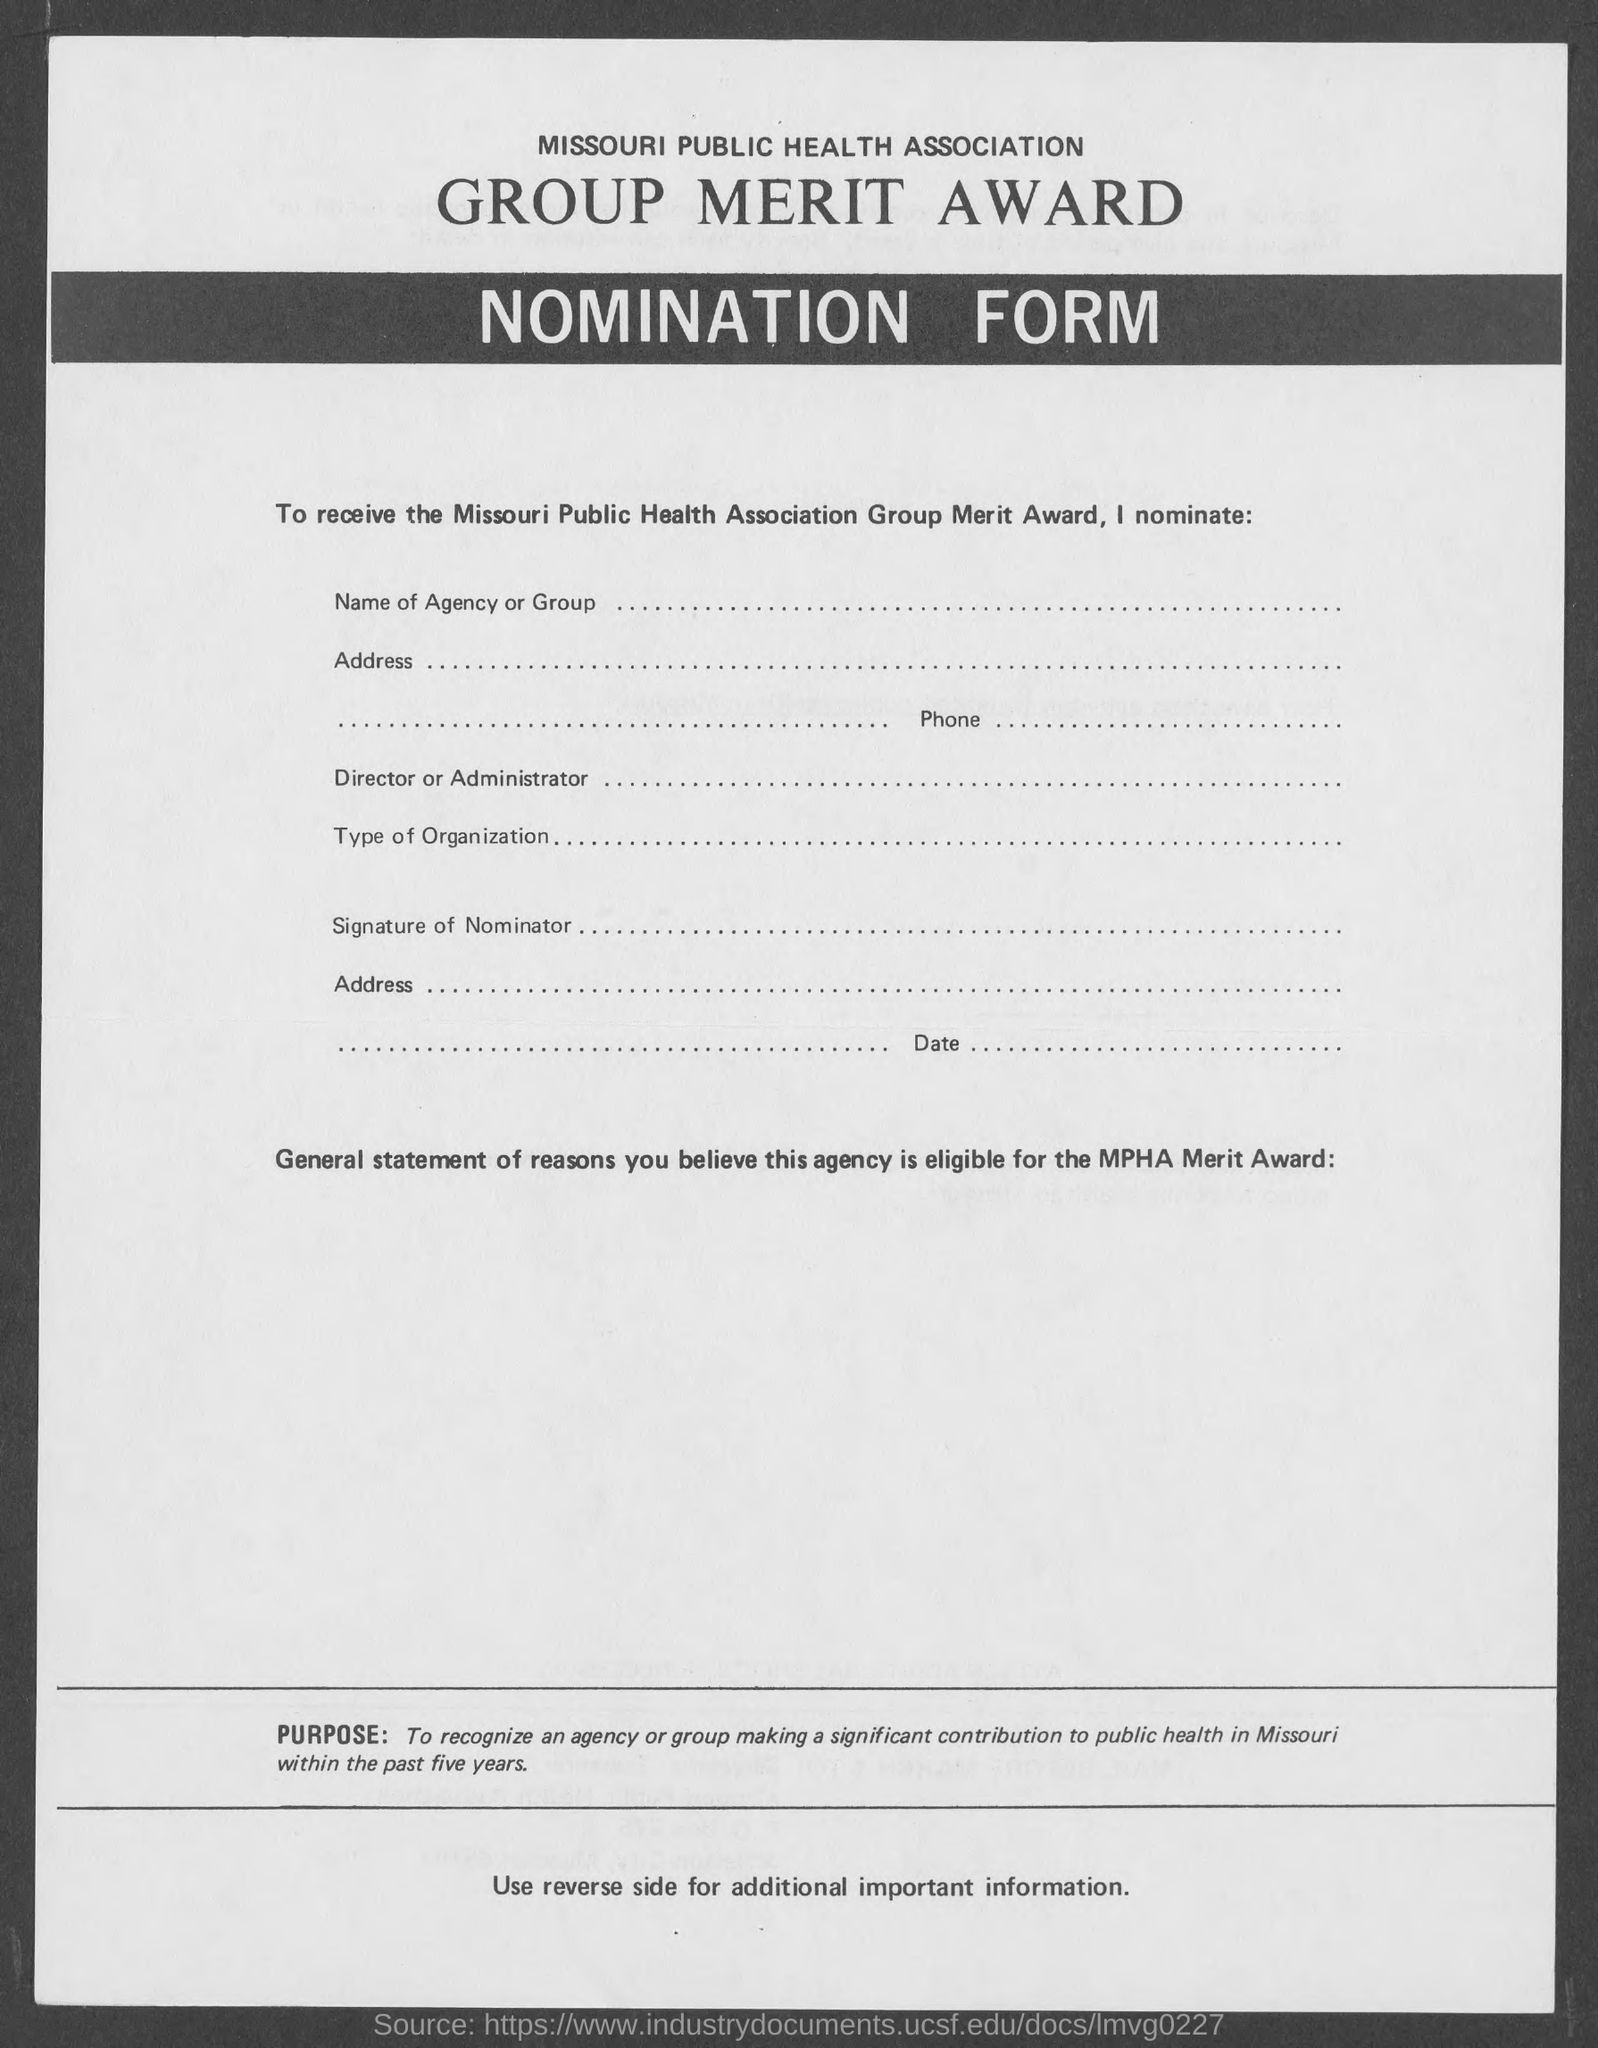What is the name of the form ?
Provide a succinct answer. Nomination form. 